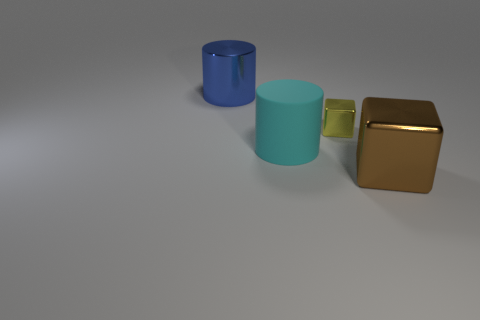Can you describe the colors of the objects in the image? Certainly! From left to right, there is a bright blue cylindrical object, a light turquoise cylindrical object with a shorter height, and a metallic brown cube. 